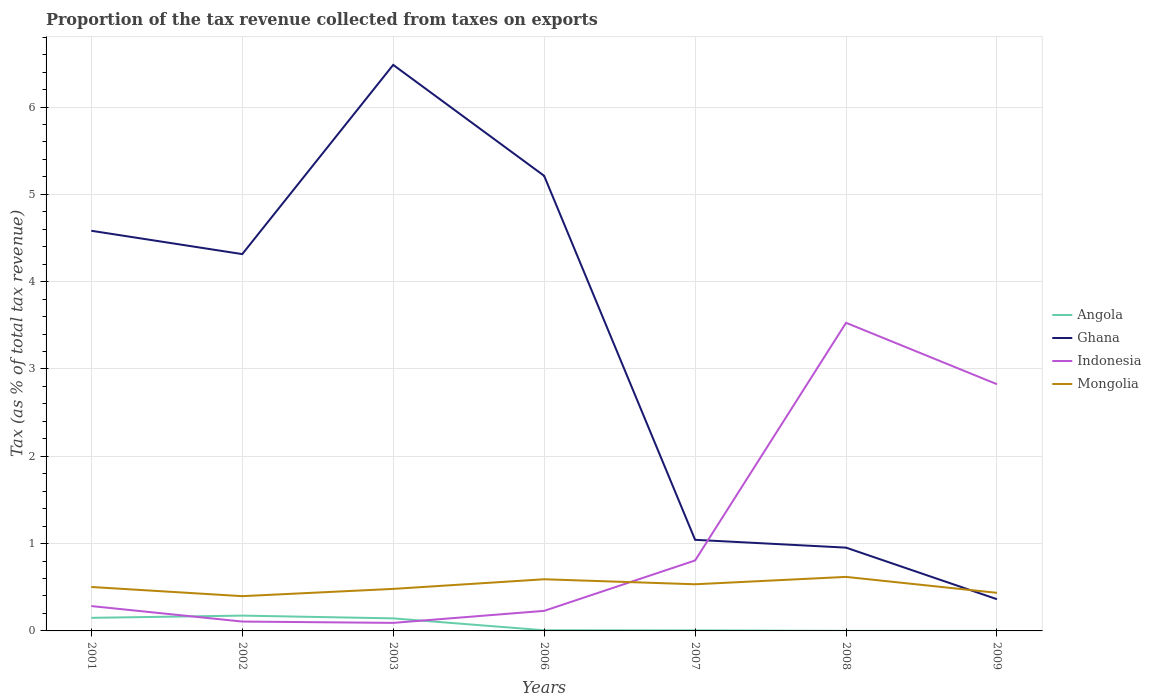How many different coloured lines are there?
Your answer should be compact. 4. Across all years, what is the maximum proportion of the tax revenue collected in Indonesia?
Make the answer very short. 0.09. In which year was the proportion of the tax revenue collected in Angola maximum?
Ensure brevity in your answer.  2008. What is the total proportion of the tax revenue collected in Mongolia in the graph?
Make the answer very short. 0.06. What is the difference between the highest and the second highest proportion of the tax revenue collected in Ghana?
Provide a short and direct response. 6.12. Is the proportion of the tax revenue collected in Ghana strictly greater than the proportion of the tax revenue collected in Mongolia over the years?
Provide a short and direct response. No. What is the difference between two consecutive major ticks on the Y-axis?
Ensure brevity in your answer.  1. Are the values on the major ticks of Y-axis written in scientific E-notation?
Provide a succinct answer. No. Does the graph contain any zero values?
Offer a terse response. No. Where does the legend appear in the graph?
Offer a very short reply. Center right. What is the title of the graph?
Provide a succinct answer. Proportion of the tax revenue collected from taxes on exports. Does "Liechtenstein" appear as one of the legend labels in the graph?
Provide a short and direct response. No. What is the label or title of the Y-axis?
Keep it short and to the point. Tax (as % of total tax revenue). What is the Tax (as % of total tax revenue) in Angola in 2001?
Ensure brevity in your answer.  0.15. What is the Tax (as % of total tax revenue) of Ghana in 2001?
Provide a succinct answer. 4.58. What is the Tax (as % of total tax revenue) of Indonesia in 2001?
Provide a succinct answer. 0.28. What is the Tax (as % of total tax revenue) of Mongolia in 2001?
Offer a very short reply. 0.5. What is the Tax (as % of total tax revenue) of Angola in 2002?
Your answer should be very brief. 0.18. What is the Tax (as % of total tax revenue) of Ghana in 2002?
Provide a short and direct response. 4.32. What is the Tax (as % of total tax revenue) in Indonesia in 2002?
Provide a succinct answer. 0.11. What is the Tax (as % of total tax revenue) of Mongolia in 2002?
Give a very brief answer. 0.4. What is the Tax (as % of total tax revenue) in Angola in 2003?
Provide a succinct answer. 0.14. What is the Tax (as % of total tax revenue) of Ghana in 2003?
Ensure brevity in your answer.  6.48. What is the Tax (as % of total tax revenue) of Indonesia in 2003?
Make the answer very short. 0.09. What is the Tax (as % of total tax revenue) in Mongolia in 2003?
Your answer should be compact. 0.48. What is the Tax (as % of total tax revenue) of Angola in 2006?
Ensure brevity in your answer.  0.01. What is the Tax (as % of total tax revenue) of Ghana in 2006?
Your answer should be compact. 5.21. What is the Tax (as % of total tax revenue) in Indonesia in 2006?
Offer a very short reply. 0.23. What is the Tax (as % of total tax revenue) in Mongolia in 2006?
Your answer should be compact. 0.59. What is the Tax (as % of total tax revenue) of Angola in 2007?
Provide a succinct answer. 0.01. What is the Tax (as % of total tax revenue) in Ghana in 2007?
Give a very brief answer. 1.04. What is the Tax (as % of total tax revenue) in Indonesia in 2007?
Keep it short and to the point. 0.81. What is the Tax (as % of total tax revenue) in Mongolia in 2007?
Make the answer very short. 0.53. What is the Tax (as % of total tax revenue) of Angola in 2008?
Your response must be concise. 0. What is the Tax (as % of total tax revenue) of Ghana in 2008?
Ensure brevity in your answer.  0.95. What is the Tax (as % of total tax revenue) in Indonesia in 2008?
Your answer should be very brief. 3.53. What is the Tax (as % of total tax revenue) of Mongolia in 2008?
Make the answer very short. 0.62. What is the Tax (as % of total tax revenue) of Angola in 2009?
Make the answer very short. 0. What is the Tax (as % of total tax revenue) of Ghana in 2009?
Offer a terse response. 0.36. What is the Tax (as % of total tax revenue) in Indonesia in 2009?
Offer a very short reply. 2.83. What is the Tax (as % of total tax revenue) of Mongolia in 2009?
Provide a succinct answer. 0.44. Across all years, what is the maximum Tax (as % of total tax revenue) in Angola?
Your response must be concise. 0.18. Across all years, what is the maximum Tax (as % of total tax revenue) in Ghana?
Your response must be concise. 6.48. Across all years, what is the maximum Tax (as % of total tax revenue) in Indonesia?
Offer a very short reply. 3.53. Across all years, what is the maximum Tax (as % of total tax revenue) of Mongolia?
Make the answer very short. 0.62. Across all years, what is the minimum Tax (as % of total tax revenue) of Angola?
Offer a very short reply. 0. Across all years, what is the minimum Tax (as % of total tax revenue) of Ghana?
Ensure brevity in your answer.  0.36. Across all years, what is the minimum Tax (as % of total tax revenue) in Indonesia?
Offer a very short reply. 0.09. Across all years, what is the minimum Tax (as % of total tax revenue) in Mongolia?
Your answer should be compact. 0.4. What is the total Tax (as % of total tax revenue) of Angola in the graph?
Your answer should be compact. 0.48. What is the total Tax (as % of total tax revenue) of Ghana in the graph?
Ensure brevity in your answer.  22.95. What is the total Tax (as % of total tax revenue) in Indonesia in the graph?
Provide a succinct answer. 7.87. What is the total Tax (as % of total tax revenue) in Mongolia in the graph?
Make the answer very short. 3.56. What is the difference between the Tax (as % of total tax revenue) of Angola in 2001 and that in 2002?
Your response must be concise. -0.03. What is the difference between the Tax (as % of total tax revenue) of Ghana in 2001 and that in 2002?
Give a very brief answer. 0.27. What is the difference between the Tax (as % of total tax revenue) of Indonesia in 2001 and that in 2002?
Your answer should be compact. 0.18. What is the difference between the Tax (as % of total tax revenue) in Mongolia in 2001 and that in 2002?
Provide a short and direct response. 0.11. What is the difference between the Tax (as % of total tax revenue) of Angola in 2001 and that in 2003?
Your answer should be very brief. 0.01. What is the difference between the Tax (as % of total tax revenue) of Ghana in 2001 and that in 2003?
Keep it short and to the point. -1.9. What is the difference between the Tax (as % of total tax revenue) of Indonesia in 2001 and that in 2003?
Ensure brevity in your answer.  0.19. What is the difference between the Tax (as % of total tax revenue) of Mongolia in 2001 and that in 2003?
Your answer should be compact. 0.02. What is the difference between the Tax (as % of total tax revenue) of Angola in 2001 and that in 2006?
Your response must be concise. 0.14. What is the difference between the Tax (as % of total tax revenue) of Ghana in 2001 and that in 2006?
Your answer should be very brief. -0.63. What is the difference between the Tax (as % of total tax revenue) of Indonesia in 2001 and that in 2006?
Provide a short and direct response. 0.05. What is the difference between the Tax (as % of total tax revenue) in Mongolia in 2001 and that in 2006?
Your response must be concise. -0.09. What is the difference between the Tax (as % of total tax revenue) in Angola in 2001 and that in 2007?
Your answer should be very brief. 0.14. What is the difference between the Tax (as % of total tax revenue) in Ghana in 2001 and that in 2007?
Your answer should be very brief. 3.54. What is the difference between the Tax (as % of total tax revenue) of Indonesia in 2001 and that in 2007?
Make the answer very short. -0.52. What is the difference between the Tax (as % of total tax revenue) of Mongolia in 2001 and that in 2007?
Provide a short and direct response. -0.03. What is the difference between the Tax (as % of total tax revenue) of Angola in 2001 and that in 2008?
Your answer should be very brief. 0.15. What is the difference between the Tax (as % of total tax revenue) in Ghana in 2001 and that in 2008?
Ensure brevity in your answer.  3.63. What is the difference between the Tax (as % of total tax revenue) in Indonesia in 2001 and that in 2008?
Offer a terse response. -3.24. What is the difference between the Tax (as % of total tax revenue) in Mongolia in 2001 and that in 2008?
Give a very brief answer. -0.12. What is the difference between the Tax (as % of total tax revenue) of Angola in 2001 and that in 2009?
Provide a short and direct response. 0.15. What is the difference between the Tax (as % of total tax revenue) in Ghana in 2001 and that in 2009?
Provide a short and direct response. 4.22. What is the difference between the Tax (as % of total tax revenue) in Indonesia in 2001 and that in 2009?
Provide a short and direct response. -2.54. What is the difference between the Tax (as % of total tax revenue) of Mongolia in 2001 and that in 2009?
Make the answer very short. 0.07. What is the difference between the Tax (as % of total tax revenue) of Angola in 2002 and that in 2003?
Your response must be concise. 0.03. What is the difference between the Tax (as % of total tax revenue) of Ghana in 2002 and that in 2003?
Your response must be concise. -2.17. What is the difference between the Tax (as % of total tax revenue) of Indonesia in 2002 and that in 2003?
Your answer should be compact. 0.02. What is the difference between the Tax (as % of total tax revenue) in Mongolia in 2002 and that in 2003?
Provide a short and direct response. -0.08. What is the difference between the Tax (as % of total tax revenue) of Angola in 2002 and that in 2006?
Your answer should be compact. 0.17. What is the difference between the Tax (as % of total tax revenue) of Ghana in 2002 and that in 2006?
Provide a succinct answer. -0.9. What is the difference between the Tax (as % of total tax revenue) in Indonesia in 2002 and that in 2006?
Provide a short and direct response. -0.12. What is the difference between the Tax (as % of total tax revenue) of Mongolia in 2002 and that in 2006?
Give a very brief answer. -0.19. What is the difference between the Tax (as % of total tax revenue) of Angola in 2002 and that in 2007?
Make the answer very short. 0.17. What is the difference between the Tax (as % of total tax revenue) of Ghana in 2002 and that in 2007?
Offer a very short reply. 3.27. What is the difference between the Tax (as % of total tax revenue) in Indonesia in 2002 and that in 2007?
Ensure brevity in your answer.  -0.7. What is the difference between the Tax (as % of total tax revenue) of Mongolia in 2002 and that in 2007?
Your answer should be very brief. -0.14. What is the difference between the Tax (as % of total tax revenue) of Angola in 2002 and that in 2008?
Provide a short and direct response. 0.17. What is the difference between the Tax (as % of total tax revenue) of Ghana in 2002 and that in 2008?
Offer a terse response. 3.36. What is the difference between the Tax (as % of total tax revenue) of Indonesia in 2002 and that in 2008?
Provide a succinct answer. -3.42. What is the difference between the Tax (as % of total tax revenue) in Mongolia in 2002 and that in 2008?
Provide a short and direct response. -0.22. What is the difference between the Tax (as % of total tax revenue) of Angola in 2002 and that in 2009?
Offer a very short reply. 0.17. What is the difference between the Tax (as % of total tax revenue) of Ghana in 2002 and that in 2009?
Give a very brief answer. 3.95. What is the difference between the Tax (as % of total tax revenue) of Indonesia in 2002 and that in 2009?
Offer a very short reply. -2.72. What is the difference between the Tax (as % of total tax revenue) of Mongolia in 2002 and that in 2009?
Give a very brief answer. -0.04. What is the difference between the Tax (as % of total tax revenue) in Angola in 2003 and that in 2006?
Offer a terse response. 0.14. What is the difference between the Tax (as % of total tax revenue) of Ghana in 2003 and that in 2006?
Make the answer very short. 1.27. What is the difference between the Tax (as % of total tax revenue) in Indonesia in 2003 and that in 2006?
Your answer should be very brief. -0.14. What is the difference between the Tax (as % of total tax revenue) in Mongolia in 2003 and that in 2006?
Offer a terse response. -0.11. What is the difference between the Tax (as % of total tax revenue) of Angola in 2003 and that in 2007?
Your response must be concise. 0.14. What is the difference between the Tax (as % of total tax revenue) in Ghana in 2003 and that in 2007?
Give a very brief answer. 5.44. What is the difference between the Tax (as % of total tax revenue) of Indonesia in 2003 and that in 2007?
Keep it short and to the point. -0.71. What is the difference between the Tax (as % of total tax revenue) of Mongolia in 2003 and that in 2007?
Your response must be concise. -0.05. What is the difference between the Tax (as % of total tax revenue) of Angola in 2003 and that in 2008?
Offer a terse response. 0.14. What is the difference between the Tax (as % of total tax revenue) in Ghana in 2003 and that in 2008?
Provide a short and direct response. 5.53. What is the difference between the Tax (as % of total tax revenue) of Indonesia in 2003 and that in 2008?
Make the answer very short. -3.44. What is the difference between the Tax (as % of total tax revenue) in Mongolia in 2003 and that in 2008?
Keep it short and to the point. -0.14. What is the difference between the Tax (as % of total tax revenue) in Angola in 2003 and that in 2009?
Ensure brevity in your answer.  0.14. What is the difference between the Tax (as % of total tax revenue) in Ghana in 2003 and that in 2009?
Make the answer very short. 6.12. What is the difference between the Tax (as % of total tax revenue) in Indonesia in 2003 and that in 2009?
Provide a succinct answer. -2.73. What is the difference between the Tax (as % of total tax revenue) of Mongolia in 2003 and that in 2009?
Your answer should be very brief. 0.05. What is the difference between the Tax (as % of total tax revenue) in Angola in 2006 and that in 2007?
Make the answer very short. 0. What is the difference between the Tax (as % of total tax revenue) in Ghana in 2006 and that in 2007?
Give a very brief answer. 4.17. What is the difference between the Tax (as % of total tax revenue) in Indonesia in 2006 and that in 2007?
Offer a very short reply. -0.58. What is the difference between the Tax (as % of total tax revenue) of Mongolia in 2006 and that in 2007?
Keep it short and to the point. 0.06. What is the difference between the Tax (as % of total tax revenue) of Angola in 2006 and that in 2008?
Your answer should be very brief. 0.01. What is the difference between the Tax (as % of total tax revenue) of Ghana in 2006 and that in 2008?
Offer a terse response. 4.26. What is the difference between the Tax (as % of total tax revenue) in Indonesia in 2006 and that in 2008?
Your answer should be very brief. -3.3. What is the difference between the Tax (as % of total tax revenue) in Mongolia in 2006 and that in 2008?
Your answer should be very brief. -0.03. What is the difference between the Tax (as % of total tax revenue) in Angola in 2006 and that in 2009?
Offer a terse response. 0.01. What is the difference between the Tax (as % of total tax revenue) of Ghana in 2006 and that in 2009?
Make the answer very short. 4.85. What is the difference between the Tax (as % of total tax revenue) in Indonesia in 2006 and that in 2009?
Offer a terse response. -2.6. What is the difference between the Tax (as % of total tax revenue) of Mongolia in 2006 and that in 2009?
Offer a very short reply. 0.16. What is the difference between the Tax (as % of total tax revenue) in Angola in 2007 and that in 2008?
Give a very brief answer. 0.01. What is the difference between the Tax (as % of total tax revenue) in Ghana in 2007 and that in 2008?
Your answer should be very brief. 0.09. What is the difference between the Tax (as % of total tax revenue) in Indonesia in 2007 and that in 2008?
Offer a very short reply. -2.72. What is the difference between the Tax (as % of total tax revenue) of Mongolia in 2007 and that in 2008?
Ensure brevity in your answer.  -0.08. What is the difference between the Tax (as % of total tax revenue) of Angola in 2007 and that in 2009?
Offer a terse response. 0.01. What is the difference between the Tax (as % of total tax revenue) in Ghana in 2007 and that in 2009?
Offer a terse response. 0.68. What is the difference between the Tax (as % of total tax revenue) in Indonesia in 2007 and that in 2009?
Offer a very short reply. -2.02. What is the difference between the Tax (as % of total tax revenue) in Mongolia in 2007 and that in 2009?
Keep it short and to the point. 0.1. What is the difference between the Tax (as % of total tax revenue) of Angola in 2008 and that in 2009?
Keep it short and to the point. -0. What is the difference between the Tax (as % of total tax revenue) in Ghana in 2008 and that in 2009?
Give a very brief answer. 0.59. What is the difference between the Tax (as % of total tax revenue) in Indonesia in 2008 and that in 2009?
Your answer should be compact. 0.7. What is the difference between the Tax (as % of total tax revenue) of Mongolia in 2008 and that in 2009?
Keep it short and to the point. 0.18. What is the difference between the Tax (as % of total tax revenue) in Angola in 2001 and the Tax (as % of total tax revenue) in Ghana in 2002?
Give a very brief answer. -4.17. What is the difference between the Tax (as % of total tax revenue) in Angola in 2001 and the Tax (as % of total tax revenue) in Indonesia in 2002?
Provide a succinct answer. 0.04. What is the difference between the Tax (as % of total tax revenue) in Angola in 2001 and the Tax (as % of total tax revenue) in Mongolia in 2002?
Give a very brief answer. -0.25. What is the difference between the Tax (as % of total tax revenue) of Ghana in 2001 and the Tax (as % of total tax revenue) of Indonesia in 2002?
Ensure brevity in your answer.  4.48. What is the difference between the Tax (as % of total tax revenue) in Ghana in 2001 and the Tax (as % of total tax revenue) in Mongolia in 2002?
Your answer should be very brief. 4.18. What is the difference between the Tax (as % of total tax revenue) of Indonesia in 2001 and the Tax (as % of total tax revenue) of Mongolia in 2002?
Offer a terse response. -0.11. What is the difference between the Tax (as % of total tax revenue) in Angola in 2001 and the Tax (as % of total tax revenue) in Ghana in 2003?
Your response must be concise. -6.33. What is the difference between the Tax (as % of total tax revenue) of Angola in 2001 and the Tax (as % of total tax revenue) of Indonesia in 2003?
Provide a succinct answer. 0.06. What is the difference between the Tax (as % of total tax revenue) in Angola in 2001 and the Tax (as % of total tax revenue) in Mongolia in 2003?
Your answer should be very brief. -0.33. What is the difference between the Tax (as % of total tax revenue) of Ghana in 2001 and the Tax (as % of total tax revenue) of Indonesia in 2003?
Provide a succinct answer. 4.49. What is the difference between the Tax (as % of total tax revenue) in Ghana in 2001 and the Tax (as % of total tax revenue) in Mongolia in 2003?
Offer a very short reply. 4.1. What is the difference between the Tax (as % of total tax revenue) in Indonesia in 2001 and the Tax (as % of total tax revenue) in Mongolia in 2003?
Offer a terse response. -0.2. What is the difference between the Tax (as % of total tax revenue) in Angola in 2001 and the Tax (as % of total tax revenue) in Ghana in 2006?
Your response must be concise. -5.06. What is the difference between the Tax (as % of total tax revenue) of Angola in 2001 and the Tax (as % of total tax revenue) of Indonesia in 2006?
Your answer should be very brief. -0.08. What is the difference between the Tax (as % of total tax revenue) of Angola in 2001 and the Tax (as % of total tax revenue) of Mongolia in 2006?
Ensure brevity in your answer.  -0.44. What is the difference between the Tax (as % of total tax revenue) in Ghana in 2001 and the Tax (as % of total tax revenue) in Indonesia in 2006?
Offer a terse response. 4.35. What is the difference between the Tax (as % of total tax revenue) of Ghana in 2001 and the Tax (as % of total tax revenue) of Mongolia in 2006?
Your answer should be compact. 3.99. What is the difference between the Tax (as % of total tax revenue) of Indonesia in 2001 and the Tax (as % of total tax revenue) of Mongolia in 2006?
Your answer should be compact. -0.31. What is the difference between the Tax (as % of total tax revenue) in Angola in 2001 and the Tax (as % of total tax revenue) in Ghana in 2007?
Offer a very short reply. -0.89. What is the difference between the Tax (as % of total tax revenue) in Angola in 2001 and the Tax (as % of total tax revenue) in Indonesia in 2007?
Keep it short and to the point. -0.66. What is the difference between the Tax (as % of total tax revenue) of Angola in 2001 and the Tax (as % of total tax revenue) of Mongolia in 2007?
Make the answer very short. -0.38. What is the difference between the Tax (as % of total tax revenue) of Ghana in 2001 and the Tax (as % of total tax revenue) of Indonesia in 2007?
Keep it short and to the point. 3.78. What is the difference between the Tax (as % of total tax revenue) in Ghana in 2001 and the Tax (as % of total tax revenue) in Mongolia in 2007?
Make the answer very short. 4.05. What is the difference between the Tax (as % of total tax revenue) of Indonesia in 2001 and the Tax (as % of total tax revenue) of Mongolia in 2007?
Your answer should be compact. -0.25. What is the difference between the Tax (as % of total tax revenue) of Angola in 2001 and the Tax (as % of total tax revenue) of Ghana in 2008?
Ensure brevity in your answer.  -0.8. What is the difference between the Tax (as % of total tax revenue) of Angola in 2001 and the Tax (as % of total tax revenue) of Indonesia in 2008?
Offer a terse response. -3.38. What is the difference between the Tax (as % of total tax revenue) of Angola in 2001 and the Tax (as % of total tax revenue) of Mongolia in 2008?
Provide a short and direct response. -0.47. What is the difference between the Tax (as % of total tax revenue) of Ghana in 2001 and the Tax (as % of total tax revenue) of Indonesia in 2008?
Ensure brevity in your answer.  1.05. What is the difference between the Tax (as % of total tax revenue) in Ghana in 2001 and the Tax (as % of total tax revenue) in Mongolia in 2008?
Offer a very short reply. 3.96. What is the difference between the Tax (as % of total tax revenue) of Indonesia in 2001 and the Tax (as % of total tax revenue) of Mongolia in 2008?
Keep it short and to the point. -0.33. What is the difference between the Tax (as % of total tax revenue) of Angola in 2001 and the Tax (as % of total tax revenue) of Ghana in 2009?
Your answer should be very brief. -0.21. What is the difference between the Tax (as % of total tax revenue) of Angola in 2001 and the Tax (as % of total tax revenue) of Indonesia in 2009?
Your response must be concise. -2.68. What is the difference between the Tax (as % of total tax revenue) of Angola in 2001 and the Tax (as % of total tax revenue) of Mongolia in 2009?
Your answer should be very brief. -0.29. What is the difference between the Tax (as % of total tax revenue) in Ghana in 2001 and the Tax (as % of total tax revenue) in Indonesia in 2009?
Offer a very short reply. 1.76. What is the difference between the Tax (as % of total tax revenue) of Ghana in 2001 and the Tax (as % of total tax revenue) of Mongolia in 2009?
Your answer should be compact. 4.15. What is the difference between the Tax (as % of total tax revenue) of Indonesia in 2001 and the Tax (as % of total tax revenue) of Mongolia in 2009?
Offer a very short reply. -0.15. What is the difference between the Tax (as % of total tax revenue) of Angola in 2002 and the Tax (as % of total tax revenue) of Ghana in 2003?
Provide a short and direct response. -6.31. What is the difference between the Tax (as % of total tax revenue) of Angola in 2002 and the Tax (as % of total tax revenue) of Indonesia in 2003?
Your response must be concise. 0.08. What is the difference between the Tax (as % of total tax revenue) in Angola in 2002 and the Tax (as % of total tax revenue) in Mongolia in 2003?
Provide a short and direct response. -0.31. What is the difference between the Tax (as % of total tax revenue) of Ghana in 2002 and the Tax (as % of total tax revenue) of Indonesia in 2003?
Give a very brief answer. 4.22. What is the difference between the Tax (as % of total tax revenue) of Ghana in 2002 and the Tax (as % of total tax revenue) of Mongolia in 2003?
Provide a succinct answer. 3.83. What is the difference between the Tax (as % of total tax revenue) of Indonesia in 2002 and the Tax (as % of total tax revenue) of Mongolia in 2003?
Your answer should be very brief. -0.37. What is the difference between the Tax (as % of total tax revenue) in Angola in 2002 and the Tax (as % of total tax revenue) in Ghana in 2006?
Your answer should be compact. -5.04. What is the difference between the Tax (as % of total tax revenue) in Angola in 2002 and the Tax (as % of total tax revenue) in Indonesia in 2006?
Provide a short and direct response. -0.05. What is the difference between the Tax (as % of total tax revenue) in Angola in 2002 and the Tax (as % of total tax revenue) in Mongolia in 2006?
Make the answer very short. -0.42. What is the difference between the Tax (as % of total tax revenue) of Ghana in 2002 and the Tax (as % of total tax revenue) of Indonesia in 2006?
Ensure brevity in your answer.  4.09. What is the difference between the Tax (as % of total tax revenue) in Ghana in 2002 and the Tax (as % of total tax revenue) in Mongolia in 2006?
Provide a succinct answer. 3.72. What is the difference between the Tax (as % of total tax revenue) of Indonesia in 2002 and the Tax (as % of total tax revenue) of Mongolia in 2006?
Provide a succinct answer. -0.48. What is the difference between the Tax (as % of total tax revenue) of Angola in 2002 and the Tax (as % of total tax revenue) of Ghana in 2007?
Keep it short and to the point. -0.87. What is the difference between the Tax (as % of total tax revenue) of Angola in 2002 and the Tax (as % of total tax revenue) of Indonesia in 2007?
Give a very brief answer. -0.63. What is the difference between the Tax (as % of total tax revenue) in Angola in 2002 and the Tax (as % of total tax revenue) in Mongolia in 2007?
Your response must be concise. -0.36. What is the difference between the Tax (as % of total tax revenue) in Ghana in 2002 and the Tax (as % of total tax revenue) in Indonesia in 2007?
Your response must be concise. 3.51. What is the difference between the Tax (as % of total tax revenue) in Ghana in 2002 and the Tax (as % of total tax revenue) in Mongolia in 2007?
Your answer should be very brief. 3.78. What is the difference between the Tax (as % of total tax revenue) in Indonesia in 2002 and the Tax (as % of total tax revenue) in Mongolia in 2007?
Keep it short and to the point. -0.43. What is the difference between the Tax (as % of total tax revenue) in Angola in 2002 and the Tax (as % of total tax revenue) in Ghana in 2008?
Offer a very short reply. -0.78. What is the difference between the Tax (as % of total tax revenue) of Angola in 2002 and the Tax (as % of total tax revenue) of Indonesia in 2008?
Make the answer very short. -3.35. What is the difference between the Tax (as % of total tax revenue) of Angola in 2002 and the Tax (as % of total tax revenue) of Mongolia in 2008?
Make the answer very short. -0.44. What is the difference between the Tax (as % of total tax revenue) of Ghana in 2002 and the Tax (as % of total tax revenue) of Indonesia in 2008?
Provide a succinct answer. 0.79. What is the difference between the Tax (as % of total tax revenue) of Ghana in 2002 and the Tax (as % of total tax revenue) of Mongolia in 2008?
Make the answer very short. 3.7. What is the difference between the Tax (as % of total tax revenue) in Indonesia in 2002 and the Tax (as % of total tax revenue) in Mongolia in 2008?
Your answer should be very brief. -0.51. What is the difference between the Tax (as % of total tax revenue) of Angola in 2002 and the Tax (as % of total tax revenue) of Ghana in 2009?
Your answer should be very brief. -0.19. What is the difference between the Tax (as % of total tax revenue) in Angola in 2002 and the Tax (as % of total tax revenue) in Indonesia in 2009?
Your response must be concise. -2.65. What is the difference between the Tax (as % of total tax revenue) in Angola in 2002 and the Tax (as % of total tax revenue) in Mongolia in 2009?
Your answer should be very brief. -0.26. What is the difference between the Tax (as % of total tax revenue) in Ghana in 2002 and the Tax (as % of total tax revenue) in Indonesia in 2009?
Make the answer very short. 1.49. What is the difference between the Tax (as % of total tax revenue) in Ghana in 2002 and the Tax (as % of total tax revenue) in Mongolia in 2009?
Offer a very short reply. 3.88. What is the difference between the Tax (as % of total tax revenue) of Indonesia in 2002 and the Tax (as % of total tax revenue) of Mongolia in 2009?
Your response must be concise. -0.33. What is the difference between the Tax (as % of total tax revenue) of Angola in 2003 and the Tax (as % of total tax revenue) of Ghana in 2006?
Your answer should be very brief. -5.07. What is the difference between the Tax (as % of total tax revenue) in Angola in 2003 and the Tax (as % of total tax revenue) in Indonesia in 2006?
Offer a terse response. -0.09. What is the difference between the Tax (as % of total tax revenue) in Angola in 2003 and the Tax (as % of total tax revenue) in Mongolia in 2006?
Your response must be concise. -0.45. What is the difference between the Tax (as % of total tax revenue) in Ghana in 2003 and the Tax (as % of total tax revenue) in Indonesia in 2006?
Offer a terse response. 6.25. What is the difference between the Tax (as % of total tax revenue) in Ghana in 2003 and the Tax (as % of total tax revenue) in Mongolia in 2006?
Ensure brevity in your answer.  5.89. What is the difference between the Tax (as % of total tax revenue) of Indonesia in 2003 and the Tax (as % of total tax revenue) of Mongolia in 2006?
Offer a very short reply. -0.5. What is the difference between the Tax (as % of total tax revenue) in Angola in 2003 and the Tax (as % of total tax revenue) in Ghana in 2007?
Your answer should be compact. -0.9. What is the difference between the Tax (as % of total tax revenue) of Angola in 2003 and the Tax (as % of total tax revenue) of Indonesia in 2007?
Offer a terse response. -0.66. What is the difference between the Tax (as % of total tax revenue) in Angola in 2003 and the Tax (as % of total tax revenue) in Mongolia in 2007?
Provide a short and direct response. -0.39. What is the difference between the Tax (as % of total tax revenue) of Ghana in 2003 and the Tax (as % of total tax revenue) of Indonesia in 2007?
Offer a very short reply. 5.68. What is the difference between the Tax (as % of total tax revenue) in Ghana in 2003 and the Tax (as % of total tax revenue) in Mongolia in 2007?
Keep it short and to the point. 5.95. What is the difference between the Tax (as % of total tax revenue) in Indonesia in 2003 and the Tax (as % of total tax revenue) in Mongolia in 2007?
Your answer should be very brief. -0.44. What is the difference between the Tax (as % of total tax revenue) in Angola in 2003 and the Tax (as % of total tax revenue) in Ghana in 2008?
Your response must be concise. -0.81. What is the difference between the Tax (as % of total tax revenue) of Angola in 2003 and the Tax (as % of total tax revenue) of Indonesia in 2008?
Your response must be concise. -3.38. What is the difference between the Tax (as % of total tax revenue) of Angola in 2003 and the Tax (as % of total tax revenue) of Mongolia in 2008?
Provide a succinct answer. -0.47. What is the difference between the Tax (as % of total tax revenue) in Ghana in 2003 and the Tax (as % of total tax revenue) in Indonesia in 2008?
Ensure brevity in your answer.  2.95. What is the difference between the Tax (as % of total tax revenue) in Ghana in 2003 and the Tax (as % of total tax revenue) in Mongolia in 2008?
Make the answer very short. 5.86. What is the difference between the Tax (as % of total tax revenue) of Indonesia in 2003 and the Tax (as % of total tax revenue) of Mongolia in 2008?
Provide a succinct answer. -0.53. What is the difference between the Tax (as % of total tax revenue) of Angola in 2003 and the Tax (as % of total tax revenue) of Ghana in 2009?
Give a very brief answer. -0.22. What is the difference between the Tax (as % of total tax revenue) in Angola in 2003 and the Tax (as % of total tax revenue) in Indonesia in 2009?
Ensure brevity in your answer.  -2.68. What is the difference between the Tax (as % of total tax revenue) in Angola in 2003 and the Tax (as % of total tax revenue) in Mongolia in 2009?
Offer a terse response. -0.29. What is the difference between the Tax (as % of total tax revenue) of Ghana in 2003 and the Tax (as % of total tax revenue) of Indonesia in 2009?
Your response must be concise. 3.66. What is the difference between the Tax (as % of total tax revenue) in Ghana in 2003 and the Tax (as % of total tax revenue) in Mongolia in 2009?
Offer a terse response. 6.05. What is the difference between the Tax (as % of total tax revenue) of Indonesia in 2003 and the Tax (as % of total tax revenue) of Mongolia in 2009?
Ensure brevity in your answer.  -0.34. What is the difference between the Tax (as % of total tax revenue) in Angola in 2006 and the Tax (as % of total tax revenue) in Ghana in 2007?
Offer a terse response. -1.04. What is the difference between the Tax (as % of total tax revenue) of Angola in 2006 and the Tax (as % of total tax revenue) of Indonesia in 2007?
Provide a short and direct response. -0.8. What is the difference between the Tax (as % of total tax revenue) in Angola in 2006 and the Tax (as % of total tax revenue) in Mongolia in 2007?
Give a very brief answer. -0.53. What is the difference between the Tax (as % of total tax revenue) in Ghana in 2006 and the Tax (as % of total tax revenue) in Indonesia in 2007?
Your answer should be compact. 4.41. What is the difference between the Tax (as % of total tax revenue) of Ghana in 2006 and the Tax (as % of total tax revenue) of Mongolia in 2007?
Give a very brief answer. 4.68. What is the difference between the Tax (as % of total tax revenue) in Indonesia in 2006 and the Tax (as % of total tax revenue) in Mongolia in 2007?
Offer a terse response. -0.3. What is the difference between the Tax (as % of total tax revenue) in Angola in 2006 and the Tax (as % of total tax revenue) in Ghana in 2008?
Ensure brevity in your answer.  -0.95. What is the difference between the Tax (as % of total tax revenue) in Angola in 2006 and the Tax (as % of total tax revenue) in Indonesia in 2008?
Provide a short and direct response. -3.52. What is the difference between the Tax (as % of total tax revenue) in Angola in 2006 and the Tax (as % of total tax revenue) in Mongolia in 2008?
Offer a terse response. -0.61. What is the difference between the Tax (as % of total tax revenue) of Ghana in 2006 and the Tax (as % of total tax revenue) of Indonesia in 2008?
Your answer should be very brief. 1.68. What is the difference between the Tax (as % of total tax revenue) in Ghana in 2006 and the Tax (as % of total tax revenue) in Mongolia in 2008?
Your response must be concise. 4.59. What is the difference between the Tax (as % of total tax revenue) of Indonesia in 2006 and the Tax (as % of total tax revenue) of Mongolia in 2008?
Your response must be concise. -0.39. What is the difference between the Tax (as % of total tax revenue) in Angola in 2006 and the Tax (as % of total tax revenue) in Ghana in 2009?
Give a very brief answer. -0.36. What is the difference between the Tax (as % of total tax revenue) of Angola in 2006 and the Tax (as % of total tax revenue) of Indonesia in 2009?
Your answer should be compact. -2.82. What is the difference between the Tax (as % of total tax revenue) of Angola in 2006 and the Tax (as % of total tax revenue) of Mongolia in 2009?
Ensure brevity in your answer.  -0.43. What is the difference between the Tax (as % of total tax revenue) of Ghana in 2006 and the Tax (as % of total tax revenue) of Indonesia in 2009?
Offer a very short reply. 2.39. What is the difference between the Tax (as % of total tax revenue) of Ghana in 2006 and the Tax (as % of total tax revenue) of Mongolia in 2009?
Provide a succinct answer. 4.78. What is the difference between the Tax (as % of total tax revenue) in Indonesia in 2006 and the Tax (as % of total tax revenue) in Mongolia in 2009?
Ensure brevity in your answer.  -0.21. What is the difference between the Tax (as % of total tax revenue) in Angola in 2007 and the Tax (as % of total tax revenue) in Ghana in 2008?
Keep it short and to the point. -0.95. What is the difference between the Tax (as % of total tax revenue) in Angola in 2007 and the Tax (as % of total tax revenue) in Indonesia in 2008?
Your answer should be very brief. -3.52. What is the difference between the Tax (as % of total tax revenue) in Angola in 2007 and the Tax (as % of total tax revenue) in Mongolia in 2008?
Provide a succinct answer. -0.61. What is the difference between the Tax (as % of total tax revenue) in Ghana in 2007 and the Tax (as % of total tax revenue) in Indonesia in 2008?
Your answer should be very brief. -2.49. What is the difference between the Tax (as % of total tax revenue) of Ghana in 2007 and the Tax (as % of total tax revenue) of Mongolia in 2008?
Your response must be concise. 0.42. What is the difference between the Tax (as % of total tax revenue) of Indonesia in 2007 and the Tax (as % of total tax revenue) of Mongolia in 2008?
Your answer should be compact. 0.19. What is the difference between the Tax (as % of total tax revenue) in Angola in 2007 and the Tax (as % of total tax revenue) in Ghana in 2009?
Your response must be concise. -0.36. What is the difference between the Tax (as % of total tax revenue) in Angola in 2007 and the Tax (as % of total tax revenue) in Indonesia in 2009?
Provide a short and direct response. -2.82. What is the difference between the Tax (as % of total tax revenue) in Angola in 2007 and the Tax (as % of total tax revenue) in Mongolia in 2009?
Ensure brevity in your answer.  -0.43. What is the difference between the Tax (as % of total tax revenue) of Ghana in 2007 and the Tax (as % of total tax revenue) of Indonesia in 2009?
Your answer should be very brief. -1.78. What is the difference between the Tax (as % of total tax revenue) of Ghana in 2007 and the Tax (as % of total tax revenue) of Mongolia in 2009?
Your response must be concise. 0.61. What is the difference between the Tax (as % of total tax revenue) in Indonesia in 2007 and the Tax (as % of total tax revenue) in Mongolia in 2009?
Make the answer very short. 0.37. What is the difference between the Tax (as % of total tax revenue) in Angola in 2008 and the Tax (as % of total tax revenue) in Ghana in 2009?
Make the answer very short. -0.36. What is the difference between the Tax (as % of total tax revenue) in Angola in 2008 and the Tax (as % of total tax revenue) in Indonesia in 2009?
Make the answer very short. -2.82. What is the difference between the Tax (as % of total tax revenue) in Angola in 2008 and the Tax (as % of total tax revenue) in Mongolia in 2009?
Offer a very short reply. -0.44. What is the difference between the Tax (as % of total tax revenue) of Ghana in 2008 and the Tax (as % of total tax revenue) of Indonesia in 2009?
Make the answer very short. -1.87. What is the difference between the Tax (as % of total tax revenue) in Ghana in 2008 and the Tax (as % of total tax revenue) in Mongolia in 2009?
Ensure brevity in your answer.  0.52. What is the difference between the Tax (as % of total tax revenue) in Indonesia in 2008 and the Tax (as % of total tax revenue) in Mongolia in 2009?
Keep it short and to the point. 3.09. What is the average Tax (as % of total tax revenue) in Angola per year?
Your answer should be very brief. 0.07. What is the average Tax (as % of total tax revenue) in Ghana per year?
Provide a short and direct response. 3.28. What is the average Tax (as % of total tax revenue) in Indonesia per year?
Your response must be concise. 1.12. What is the average Tax (as % of total tax revenue) of Mongolia per year?
Offer a very short reply. 0.51. In the year 2001, what is the difference between the Tax (as % of total tax revenue) of Angola and Tax (as % of total tax revenue) of Ghana?
Give a very brief answer. -4.43. In the year 2001, what is the difference between the Tax (as % of total tax revenue) in Angola and Tax (as % of total tax revenue) in Indonesia?
Keep it short and to the point. -0.13. In the year 2001, what is the difference between the Tax (as % of total tax revenue) in Angola and Tax (as % of total tax revenue) in Mongolia?
Make the answer very short. -0.35. In the year 2001, what is the difference between the Tax (as % of total tax revenue) of Ghana and Tax (as % of total tax revenue) of Indonesia?
Provide a short and direct response. 4.3. In the year 2001, what is the difference between the Tax (as % of total tax revenue) of Ghana and Tax (as % of total tax revenue) of Mongolia?
Give a very brief answer. 4.08. In the year 2001, what is the difference between the Tax (as % of total tax revenue) in Indonesia and Tax (as % of total tax revenue) in Mongolia?
Offer a very short reply. -0.22. In the year 2002, what is the difference between the Tax (as % of total tax revenue) of Angola and Tax (as % of total tax revenue) of Ghana?
Offer a terse response. -4.14. In the year 2002, what is the difference between the Tax (as % of total tax revenue) in Angola and Tax (as % of total tax revenue) in Indonesia?
Provide a short and direct response. 0.07. In the year 2002, what is the difference between the Tax (as % of total tax revenue) of Angola and Tax (as % of total tax revenue) of Mongolia?
Offer a very short reply. -0.22. In the year 2002, what is the difference between the Tax (as % of total tax revenue) in Ghana and Tax (as % of total tax revenue) in Indonesia?
Offer a very short reply. 4.21. In the year 2002, what is the difference between the Tax (as % of total tax revenue) of Ghana and Tax (as % of total tax revenue) of Mongolia?
Keep it short and to the point. 3.92. In the year 2002, what is the difference between the Tax (as % of total tax revenue) of Indonesia and Tax (as % of total tax revenue) of Mongolia?
Ensure brevity in your answer.  -0.29. In the year 2003, what is the difference between the Tax (as % of total tax revenue) of Angola and Tax (as % of total tax revenue) of Ghana?
Keep it short and to the point. -6.34. In the year 2003, what is the difference between the Tax (as % of total tax revenue) of Angola and Tax (as % of total tax revenue) of Indonesia?
Offer a very short reply. 0.05. In the year 2003, what is the difference between the Tax (as % of total tax revenue) in Angola and Tax (as % of total tax revenue) in Mongolia?
Your answer should be very brief. -0.34. In the year 2003, what is the difference between the Tax (as % of total tax revenue) in Ghana and Tax (as % of total tax revenue) in Indonesia?
Ensure brevity in your answer.  6.39. In the year 2003, what is the difference between the Tax (as % of total tax revenue) of Ghana and Tax (as % of total tax revenue) of Mongolia?
Your answer should be very brief. 6. In the year 2003, what is the difference between the Tax (as % of total tax revenue) in Indonesia and Tax (as % of total tax revenue) in Mongolia?
Keep it short and to the point. -0.39. In the year 2006, what is the difference between the Tax (as % of total tax revenue) of Angola and Tax (as % of total tax revenue) of Ghana?
Make the answer very short. -5.2. In the year 2006, what is the difference between the Tax (as % of total tax revenue) of Angola and Tax (as % of total tax revenue) of Indonesia?
Your answer should be compact. -0.22. In the year 2006, what is the difference between the Tax (as % of total tax revenue) in Angola and Tax (as % of total tax revenue) in Mongolia?
Provide a succinct answer. -0.58. In the year 2006, what is the difference between the Tax (as % of total tax revenue) in Ghana and Tax (as % of total tax revenue) in Indonesia?
Offer a very short reply. 4.98. In the year 2006, what is the difference between the Tax (as % of total tax revenue) of Ghana and Tax (as % of total tax revenue) of Mongolia?
Provide a short and direct response. 4.62. In the year 2006, what is the difference between the Tax (as % of total tax revenue) of Indonesia and Tax (as % of total tax revenue) of Mongolia?
Provide a short and direct response. -0.36. In the year 2007, what is the difference between the Tax (as % of total tax revenue) in Angola and Tax (as % of total tax revenue) in Ghana?
Provide a short and direct response. -1.04. In the year 2007, what is the difference between the Tax (as % of total tax revenue) of Angola and Tax (as % of total tax revenue) of Indonesia?
Offer a terse response. -0.8. In the year 2007, what is the difference between the Tax (as % of total tax revenue) of Angola and Tax (as % of total tax revenue) of Mongolia?
Provide a short and direct response. -0.53. In the year 2007, what is the difference between the Tax (as % of total tax revenue) in Ghana and Tax (as % of total tax revenue) in Indonesia?
Your response must be concise. 0.24. In the year 2007, what is the difference between the Tax (as % of total tax revenue) of Ghana and Tax (as % of total tax revenue) of Mongolia?
Ensure brevity in your answer.  0.51. In the year 2007, what is the difference between the Tax (as % of total tax revenue) of Indonesia and Tax (as % of total tax revenue) of Mongolia?
Your response must be concise. 0.27. In the year 2008, what is the difference between the Tax (as % of total tax revenue) of Angola and Tax (as % of total tax revenue) of Ghana?
Provide a succinct answer. -0.95. In the year 2008, what is the difference between the Tax (as % of total tax revenue) in Angola and Tax (as % of total tax revenue) in Indonesia?
Your response must be concise. -3.53. In the year 2008, what is the difference between the Tax (as % of total tax revenue) in Angola and Tax (as % of total tax revenue) in Mongolia?
Give a very brief answer. -0.62. In the year 2008, what is the difference between the Tax (as % of total tax revenue) in Ghana and Tax (as % of total tax revenue) in Indonesia?
Provide a short and direct response. -2.57. In the year 2008, what is the difference between the Tax (as % of total tax revenue) of Ghana and Tax (as % of total tax revenue) of Mongolia?
Your response must be concise. 0.34. In the year 2008, what is the difference between the Tax (as % of total tax revenue) of Indonesia and Tax (as % of total tax revenue) of Mongolia?
Offer a very short reply. 2.91. In the year 2009, what is the difference between the Tax (as % of total tax revenue) in Angola and Tax (as % of total tax revenue) in Ghana?
Keep it short and to the point. -0.36. In the year 2009, what is the difference between the Tax (as % of total tax revenue) in Angola and Tax (as % of total tax revenue) in Indonesia?
Make the answer very short. -2.82. In the year 2009, what is the difference between the Tax (as % of total tax revenue) of Angola and Tax (as % of total tax revenue) of Mongolia?
Give a very brief answer. -0.44. In the year 2009, what is the difference between the Tax (as % of total tax revenue) of Ghana and Tax (as % of total tax revenue) of Indonesia?
Ensure brevity in your answer.  -2.46. In the year 2009, what is the difference between the Tax (as % of total tax revenue) in Ghana and Tax (as % of total tax revenue) in Mongolia?
Make the answer very short. -0.07. In the year 2009, what is the difference between the Tax (as % of total tax revenue) of Indonesia and Tax (as % of total tax revenue) of Mongolia?
Provide a succinct answer. 2.39. What is the ratio of the Tax (as % of total tax revenue) in Angola in 2001 to that in 2002?
Offer a very short reply. 0.85. What is the ratio of the Tax (as % of total tax revenue) in Ghana in 2001 to that in 2002?
Ensure brevity in your answer.  1.06. What is the ratio of the Tax (as % of total tax revenue) in Indonesia in 2001 to that in 2002?
Your response must be concise. 2.65. What is the ratio of the Tax (as % of total tax revenue) of Mongolia in 2001 to that in 2002?
Your answer should be very brief. 1.26. What is the ratio of the Tax (as % of total tax revenue) in Angola in 2001 to that in 2003?
Make the answer very short. 1.04. What is the ratio of the Tax (as % of total tax revenue) in Ghana in 2001 to that in 2003?
Provide a succinct answer. 0.71. What is the ratio of the Tax (as % of total tax revenue) in Indonesia in 2001 to that in 2003?
Provide a succinct answer. 3.09. What is the ratio of the Tax (as % of total tax revenue) of Mongolia in 2001 to that in 2003?
Make the answer very short. 1.05. What is the ratio of the Tax (as % of total tax revenue) of Angola in 2001 to that in 2006?
Offer a terse response. 19.98. What is the ratio of the Tax (as % of total tax revenue) in Ghana in 2001 to that in 2006?
Give a very brief answer. 0.88. What is the ratio of the Tax (as % of total tax revenue) of Indonesia in 2001 to that in 2006?
Provide a short and direct response. 1.24. What is the ratio of the Tax (as % of total tax revenue) of Mongolia in 2001 to that in 2006?
Provide a short and direct response. 0.85. What is the ratio of the Tax (as % of total tax revenue) of Angola in 2001 to that in 2007?
Give a very brief answer. 24.91. What is the ratio of the Tax (as % of total tax revenue) in Ghana in 2001 to that in 2007?
Ensure brevity in your answer.  4.39. What is the ratio of the Tax (as % of total tax revenue) in Indonesia in 2001 to that in 2007?
Give a very brief answer. 0.35. What is the ratio of the Tax (as % of total tax revenue) of Mongolia in 2001 to that in 2007?
Ensure brevity in your answer.  0.94. What is the ratio of the Tax (as % of total tax revenue) of Angola in 2001 to that in 2008?
Your answer should be very brief. 296.28. What is the ratio of the Tax (as % of total tax revenue) in Ghana in 2001 to that in 2008?
Keep it short and to the point. 4.8. What is the ratio of the Tax (as % of total tax revenue) of Indonesia in 2001 to that in 2008?
Offer a very short reply. 0.08. What is the ratio of the Tax (as % of total tax revenue) of Mongolia in 2001 to that in 2008?
Ensure brevity in your answer.  0.81. What is the ratio of the Tax (as % of total tax revenue) of Angola in 2001 to that in 2009?
Your answer should be compact. 236.73. What is the ratio of the Tax (as % of total tax revenue) of Ghana in 2001 to that in 2009?
Your answer should be very brief. 12.62. What is the ratio of the Tax (as % of total tax revenue) of Indonesia in 2001 to that in 2009?
Your response must be concise. 0.1. What is the ratio of the Tax (as % of total tax revenue) of Mongolia in 2001 to that in 2009?
Make the answer very short. 1.15. What is the ratio of the Tax (as % of total tax revenue) in Angola in 2002 to that in 2003?
Give a very brief answer. 1.22. What is the ratio of the Tax (as % of total tax revenue) in Ghana in 2002 to that in 2003?
Give a very brief answer. 0.67. What is the ratio of the Tax (as % of total tax revenue) of Indonesia in 2002 to that in 2003?
Your answer should be compact. 1.16. What is the ratio of the Tax (as % of total tax revenue) in Mongolia in 2002 to that in 2003?
Keep it short and to the point. 0.83. What is the ratio of the Tax (as % of total tax revenue) of Angola in 2002 to that in 2006?
Offer a very short reply. 23.4. What is the ratio of the Tax (as % of total tax revenue) in Ghana in 2002 to that in 2006?
Keep it short and to the point. 0.83. What is the ratio of the Tax (as % of total tax revenue) in Indonesia in 2002 to that in 2006?
Provide a short and direct response. 0.47. What is the ratio of the Tax (as % of total tax revenue) of Mongolia in 2002 to that in 2006?
Offer a terse response. 0.67. What is the ratio of the Tax (as % of total tax revenue) in Angola in 2002 to that in 2007?
Make the answer very short. 29.18. What is the ratio of the Tax (as % of total tax revenue) in Ghana in 2002 to that in 2007?
Your answer should be compact. 4.14. What is the ratio of the Tax (as % of total tax revenue) of Indonesia in 2002 to that in 2007?
Offer a terse response. 0.13. What is the ratio of the Tax (as % of total tax revenue) of Mongolia in 2002 to that in 2007?
Provide a succinct answer. 0.74. What is the ratio of the Tax (as % of total tax revenue) in Angola in 2002 to that in 2008?
Your answer should be very brief. 347.06. What is the ratio of the Tax (as % of total tax revenue) in Ghana in 2002 to that in 2008?
Make the answer very short. 4.52. What is the ratio of the Tax (as % of total tax revenue) of Indonesia in 2002 to that in 2008?
Your answer should be compact. 0.03. What is the ratio of the Tax (as % of total tax revenue) of Mongolia in 2002 to that in 2008?
Provide a succinct answer. 0.64. What is the ratio of the Tax (as % of total tax revenue) in Angola in 2002 to that in 2009?
Provide a succinct answer. 277.3. What is the ratio of the Tax (as % of total tax revenue) of Ghana in 2002 to that in 2009?
Offer a very short reply. 11.89. What is the ratio of the Tax (as % of total tax revenue) in Indonesia in 2002 to that in 2009?
Ensure brevity in your answer.  0.04. What is the ratio of the Tax (as % of total tax revenue) of Mongolia in 2002 to that in 2009?
Your response must be concise. 0.91. What is the ratio of the Tax (as % of total tax revenue) of Angola in 2003 to that in 2006?
Ensure brevity in your answer.  19.18. What is the ratio of the Tax (as % of total tax revenue) in Ghana in 2003 to that in 2006?
Provide a succinct answer. 1.24. What is the ratio of the Tax (as % of total tax revenue) in Indonesia in 2003 to that in 2006?
Your response must be concise. 0.4. What is the ratio of the Tax (as % of total tax revenue) in Mongolia in 2003 to that in 2006?
Keep it short and to the point. 0.81. What is the ratio of the Tax (as % of total tax revenue) of Angola in 2003 to that in 2007?
Keep it short and to the point. 23.93. What is the ratio of the Tax (as % of total tax revenue) in Ghana in 2003 to that in 2007?
Offer a very short reply. 6.21. What is the ratio of the Tax (as % of total tax revenue) in Indonesia in 2003 to that in 2007?
Provide a short and direct response. 0.11. What is the ratio of the Tax (as % of total tax revenue) of Mongolia in 2003 to that in 2007?
Make the answer very short. 0.9. What is the ratio of the Tax (as % of total tax revenue) of Angola in 2003 to that in 2008?
Your answer should be compact. 284.51. What is the ratio of the Tax (as % of total tax revenue) of Ghana in 2003 to that in 2008?
Offer a very short reply. 6.8. What is the ratio of the Tax (as % of total tax revenue) in Indonesia in 2003 to that in 2008?
Your response must be concise. 0.03. What is the ratio of the Tax (as % of total tax revenue) of Mongolia in 2003 to that in 2008?
Your response must be concise. 0.78. What is the ratio of the Tax (as % of total tax revenue) of Angola in 2003 to that in 2009?
Make the answer very short. 227.32. What is the ratio of the Tax (as % of total tax revenue) of Ghana in 2003 to that in 2009?
Your response must be concise. 17.85. What is the ratio of the Tax (as % of total tax revenue) in Indonesia in 2003 to that in 2009?
Keep it short and to the point. 0.03. What is the ratio of the Tax (as % of total tax revenue) in Mongolia in 2003 to that in 2009?
Offer a very short reply. 1.1. What is the ratio of the Tax (as % of total tax revenue) in Angola in 2006 to that in 2007?
Your response must be concise. 1.25. What is the ratio of the Tax (as % of total tax revenue) of Ghana in 2006 to that in 2007?
Offer a very short reply. 5. What is the ratio of the Tax (as % of total tax revenue) of Indonesia in 2006 to that in 2007?
Your answer should be very brief. 0.28. What is the ratio of the Tax (as % of total tax revenue) in Mongolia in 2006 to that in 2007?
Give a very brief answer. 1.11. What is the ratio of the Tax (as % of total tax revenue) in Angola in 2006 to that in 2008?
Ensure brevity in your answer.  14.83. What is the ratio of the Tax (as % of total tax revenue) in Ghana in 2006 to that in 2008?
Provide a short and direct response. 5.46. What is the ratio of the Tax (as % of total tax revenue) in Indonesia in 2006 to that in 2008?
Your response must be concise. 0.07. What is the ratio of the Tax (as % of total tax revenue) in Mongolia in 2006 to that in 2008?
Your answer should be very brief. 0.96. What is the ratio of the Tax (as % of total tax revenue) in Angola in 2006 to that in 2009?
Provide a succinct answer. 11.85. What is the ratio of the Tax (as % of total tax revenue) of Ghana in 2006 to that in 2009?
Make the answer very short. 14.35. What is the ratio of the Tax (as % of total tax revenue) in Indonesia in 2006 to that in 2009?
Make the answer very short. 0.08. What is the ratio of the Tax (as % of total tax revenue) of Mongolia in 2006 to that in 2009?
Give a very brief answer. 1.36. What is the ratio of the Tax (as % of total tax revenue) in Angola in 2007 to that in 2008?
Your answer should be compact. 11.89. What is the ratio of the Tax (as % of total tax revenue) in Ghana in 2007 to that in 2008?
Keep it short and to the point. 1.09. What is the ratio of the Tax (as % of total tax revenue) of Indonesia in 2007 to that in 2008?
Ensure brevity in your answer.  0.23. What is the ratio of the Tax (as % of total tax revenue) in Mongolia in 2007 to that in 2008?
Make the answer very short. 0.86. What is the ratio of the Tax (as % of total tax revenue) of Angola in 2007 to that in 2009?
Provide a short and direct response. 9.5. What is the ratio of the Tax (as % of total tax revenue) in Ghana in 2007 to that in 2009?
Ensure brevity in your answer.  2.87. What is the ratio of the Tax (as % of total tax revenue) of Indonesia in 2007 to that in 2009?
Your response must be concise. 0.29. What is the ratio of the Tax (as % of total tax revenue) of Mongolia in 2007 to that in 2009?
Your answer should be very brief. 1.23. What is the ratio of the Tax (as % of total tax revenue) in Angola in 2008 to that in 2009?
Provide a succinct answer. 0.8. What is the ratio of the Tax (as % of total tax revenue) in Ghana in 2008 to that in 2009?
Offer a terse response. 2.63. What is the ratio of the Tax (as % of total tax revenue) in Indonesia in 2008 to that in 2009?
Your answer should be very brief. 1.25. What is the ratio of the Tax (as % of total tax revenue) in Mongolia in 2008 to that in 2009?
Your answer should be very brief. 1.42. What is the difference between the highest and the second highest Tax (as % of total tax revenue) of Angola?
Offer a terse response. 0.03. What is the difference between the highest and the second highest Tax (as % of total tax revenue) of Ghana?
Your answer should be compact. 1.27. What is the difference between the highest and the second highest Tax (as % of total tax revenue) of Indonesia?
Keep it short and to the point. 0.7. What is the difference between the highest and the second highest Tax (as % of total tax revenue) of Mongolia?
Keep it short and to the point. 0.03. What is the difference between the highest and the lowest Tax (as % of total tax revenue) in Angola?
Offer a very short reply. 0.17. What is the difference between the highest and the lowest Tax (as % of total tax revenue) of Ghana?
Keep it short and to the point. 6.12. What is the difference between the highest and the lowest Tax (as % of total tax revenue) of Indonesia?
Your response must be concise. 3.44. What is the difference between the highest and the lowest Tax (as % of total tax revenue) of Mongolia?
Offer a very short reply. 0.22. 